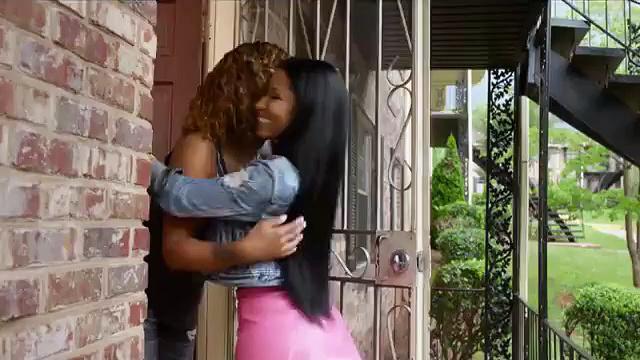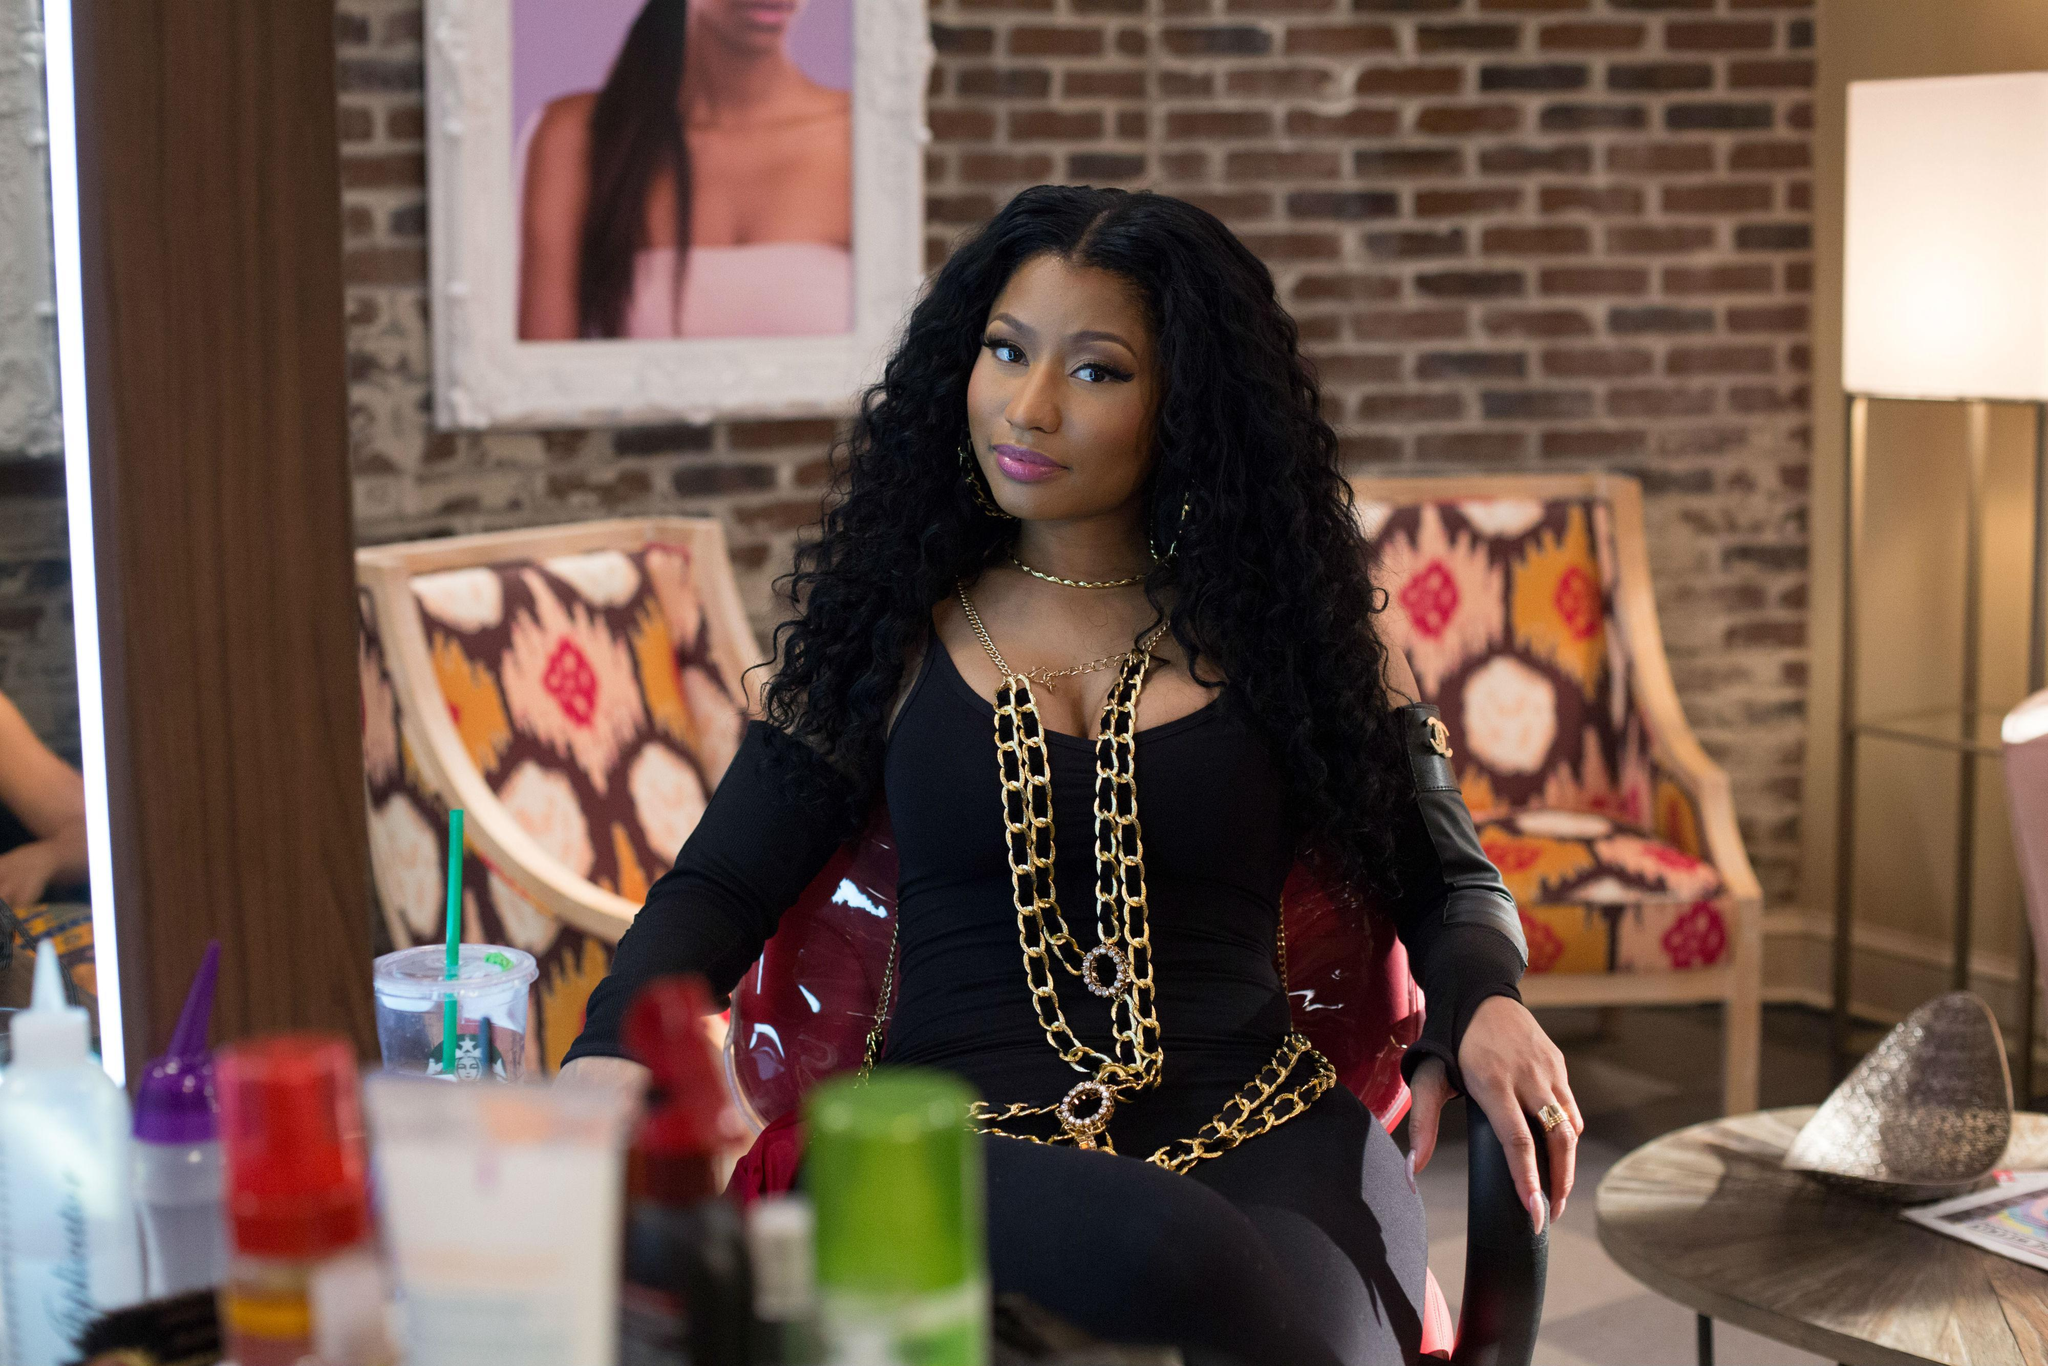The first image is the image on the left, the second image is the image on the right. Considering the images on both sides, is "She is wearing the same necklace in every single image." valid? Answer yes or no. No. The first image is the image on the left, the second image is the image on the right. Analyze the images presented: Is the assertion "One of the images has two different women." valid? Answer yes or no. Yes. 